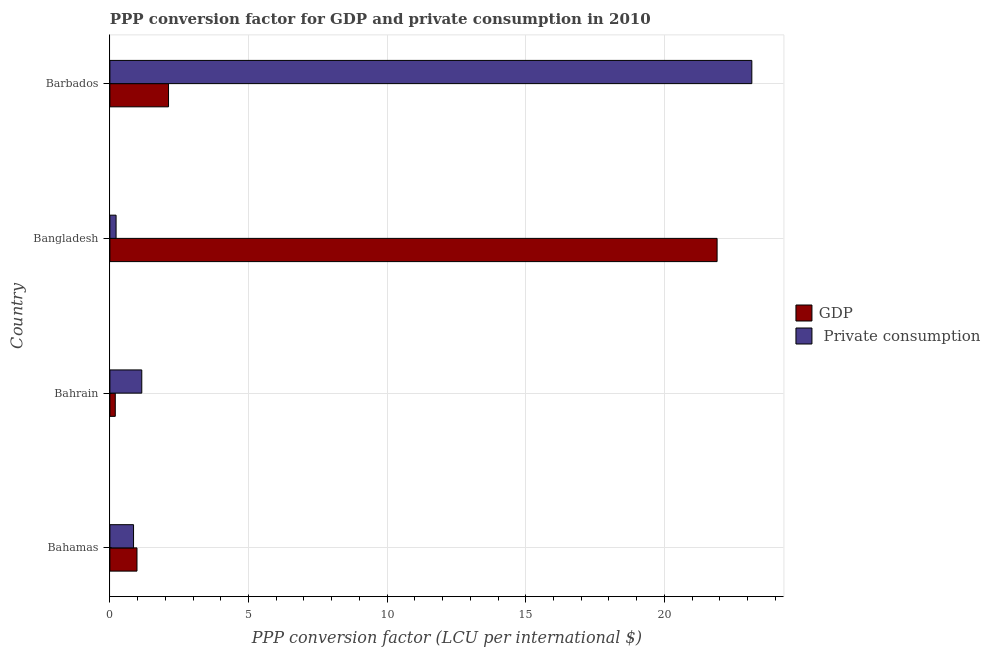Are the number of bars on each tick of the Y-axis equal?
Your answer should be very brief. Yes. How many bars are there on the 3rd tick from the top?
Make the answer very short. 2. How many bars are there on the 2nd tick from the bottom?
Your response must be concise. 2. What is the label of the 4th group of bars from the top?
Keep it short and to the point. Bahamas. In how many cases, is the number of bars for a given country not equal to the number of legend labels?
Your answer should be compact. 0. What is the ppp conversion factor for private consumption in Bahamas?
Your answer should be compact. 0.85. Across all countries, what is the maximum ppp conversion factor for gdp?
Ensure brevity in your answer.  21.9. Across all countries, what is the minimum ppp conversion factor for gdp?
Your answer should be very brief. 0.19. In which country was the ppp conversion factor for private consumption maximum?
Give a very brief answer. Barbados. In which country was the ppp conversion factor for gdp minimum?
Ensure brevity in your answer.  Bahrain. What is the total ppp conversion factor for private consumption in the graph?
Keep it short and to the point. 25.38. What is the difference between the ppp conversion factor for gdp in Bahrain and that in Barbados?
Offer a very short reply. -1.92. What is the difference between the ppp conversion factor for gdp in Bangladesh and the ppp conversion factor for private consumption in Bahamas?
Provide a short and direct response. 21.05. What is the average ppp conversion factor for gdp per country?
Make the answer very short. 6.3. What is the difference between the ppp conversion factor for private consumption and ppp conversion factor for gdp in Bangladesh?
Offer a terse response. -21.68. In how many countries, is the ppp conversion factor for gdp greater than 6 LCU?
Your answer should be compact. 1. What is the ratio of the ppp conversion factor for gdp in Bahamas to that in Bangladesh?
Give a very brief answer. 0.04. Is the ppp conversion factor for private consumption in Bahamas less than that in Barbados?
Ensure brevity in your answer.  Yes. What is the difference between the highest and the second highest ppp conversion factor for private consumption?
Ensure brevity in your answer.  22. What is the difference between the highest and the lowest ppp conversion factor for gdp?
Provide a succinct answer. 21.71. Is the sum of the ppp conversion factor for gdp in Bangladesh and Barbados greater than the maximum ppp conversion factor for private consumption across all countries?
Provide a succinct answer. Yes. What does the 1st bar from the top in Bahrain represents?
Keep it short and to the point.  Private consumption. What does the 1st bar from the bottom in Bahamas represents?
Offer a very short reply. GDP. Are all the bars in the graph horizontal?
Your response must be concise. Yes. How many countries are there in the graph?
Your answer should be very brief. 4. What is the difference between two consecutive major ticks on the X-axis?
Your answer should be very brief. 5. Are the values on the major ticks of X-axis written in scientific E-notation?
Provide a short and direct response. No. Where does the legend appear in the graph?
Keep it short and to the point. Center right. How many legend labels are there?
Give a very brief answer. 2. How are the legend labels stacked?
Give a very brief answer. Vertical. What is the title of the graph?
Keep it short and to the point. PPP conversion factor for GDP and private consumption in 2010. Does "Nitrous oxide emissions" appear as one of the legend labels in the graph?
Offer a very short reply. No. What is the label or title of the X-axis?
Ensure brevity in your answer.  PPP conversion factor (LCU per international $). What is the label or title of the Y-axis?
Provide a short and direct response. Country. What is the PPP conversion factor (LCU per international $) in GDP in Bahamas?
Offer a very short reply. 0.98. What is the PPP conversion factor (LCU per international $) of  Private consumption in Bahamas?
Provide a short and direct response. 0.85. What is the PPP conversion factor (LCU per international $) of GDP in Bahrain?
Provide a succinct answer. 0.19. What is the PPP conversion factor (LCU per international $) of  Private consumption in Bahrain?
Offer a very short reply. 1.15. What is the PPP conversion factor (LCU per international $) of GDP in Bangladesh?
Make the answer very short. 21.9. What is the PPP conversion factor (LCU per international $) of  Private consumption in Bangladesh?
Make the answer very short. 0.22. What is the PPP conversion factor (LCU per international $) in GDP in Barbados?
Your answer should be very brief. 2.12. What is the PPP conversion factor (LCU per international $) in  Private consumption in Barbados?
Give a very brief answer. 23.15. Across all countries, what is the maximum PPP conversion factor (LCU per international $) in GDP?
Give a very brief answer. 21.9. Across all countries, what is the maximum PPP conversion factor (LCU per international $) of  Private consumption?
Your answer should be very brief. 23.15. Across all countries, what is the minimum PPP conversion factor (LCU per international $) of GDP?
Give a very brief answer. 0.19. Across all countries, what is the minimum PPP conversion factor (LCU per international $) in  Private consumption?
Your response must be concise. 0.22. What is the total PPP conversion factor (LCU per international $) of GDP in the graph?
Your response must be concise. 25.19. What is the total PPP conversion factor (LCU per international $) of  Private consumption in the graph?
Offer a terse response. 25.38. What is the difference between the PPP conversion factor (LCU per international $) in GDP in Bahamas and that in Bahrain?
Make the answer very short. 0.78. What is the difference between the PPP conversion factor (LCU per international $) of  Private consumption in Bahamas and that in Bahrain?
Offer a very short reply. -0.3. What is the difference between the PPP conversion factor (LCU per international $) of GDP in Bahamas and that in Bangladesh?
Make the answer very short. -20.92. What is the difference between the PPP conversion factor (LCU per international $) of  Private consumption in Bahamas and that in Bangladesh?
Keep it short and to the point. 0.63. What is the difference between the PPP conversion factor (LCU per international $) in GDP in Bahamas and that in Barbados?
Keep it short and to the point. -1.14. What is the difference between the PPP conversion factor (LCU per international $) of  Private consumption in Bahamas and that in Barbados?
Offer a very short reply. -22.3. What is the difference between the PPP conversion factor (LCU per international $) in GDP in Bahrain and that in Bangladesh?
Provide a short and direct response. -21.71. What is the difference between the PPP conversion factor (LCU per international $) of  Private consumption in Bahrain and that in Bangladesh?
Give a very brief answer. 0.93. What is the difference between the PPP conversion factor (LCU per international $) in GDP in Bahrain and that in Barbados?
Offer a terse response. -1.92. What is the difference between the PPP conversion factor (LCU per international $) of  Private consumption in Bahrain and that in Barbados?
Provide a short and direct response. -22. What is the difference between the PPP conversion factor (LCU per international $) of GDP in Bangladesh and that in Barbados?
Your answer should be compact. 19.79. What is the difference between the PPP conversion factor (LCU per international $) in  Private consumption in Bangladesh and that in Barbados?
Provide a short and direct response. -22.93. What is the difference between the PPP conversion factor (LCU per international $) in GDP in Bahamas and the PPP conversion factor (LCU per international $) in  Private consumption in Bahrain?
Ensure brevity in your answer.  -0.17. What is the difference between the PPP conversion factor (LCU per international $) of GDP in Bahamas and the PPP conversion factor (LCU per international $) of  Private consumption in Bangladesh?
Provide a short and direct response. 0.75. What is the difference between the PPP conversion factor (LCU per international $) of GDP in Bahamas and the PPP conversion factor (LCU per international $) of  Private consumption in Barbados?
Your answer should be compact. -22.18. What is the difference between the PPP conversion factor (LCU per international $) of GDP in Bahrain and the PPP conversion factor (LCU per international $) of  Private consumption in Bangladesh?
Provide a succinct answer. -0.03. What is the difference between the PPP conversion factor (LCU per international $) of GDP in Bahrain and the PPP conversion factor (LCU per international $) of  Private consumption in Barbados?
Provide a succinct answer. -22.96. What is the difference between the PPP conversion factor (LCU per international $) in GDP in Bangladesh and the PPP conversion factor (LCU per international $) in  Private consumption in Barbados?
Your response must be concise. -1.25. What is the average PPP conversion factor (LCU per international $) in GDP per country?
Ensure brevity in your answer.  6.3. What is the average PPP conversion factor (LCU per international $) of  Private consumption per country?
Make the answer very short. 6.35. What is the difference between the PPP conversion factor (LCU per international $) in GDP and PPP conversion factor (LCU per international $) in  Private consumption in Bahamas?
Keep it short and to the point. 0.12. What is the difference between the PPP conversion factor (LCU per international $) in GDP and PPP conversion factor (LCU per international $) in  Private consumption in Bahrain?
Offer a terse response. -0.96. What is the difference between the PPP conversion factor (LCU per international $) in GDP and PPP conversion factor (LCU per international $) in  Private consumption in Bangladesh?
Your answer should be very brief. 21.68. What is the difference between the PPP conversion factor (LCU per international $) of GDP and PPP conversion factor (LCU per international $) of  Private consumption in Barbados?
Provide a short and direct response. -21.04. What is the ratio of the PPP conversion factor (LCU per international $) of GDP in Bahamas to that in Bahrain?
Provide a succinct answer. 5.03. What is the ratio of the PPP conversion factor (LCU per international $) in  Private consumption in Bahamas to that in Bahrain?
Offer a terse response. 0.74. What is the ratio of the PPP conversion factor (LCU per international $) in GDP in Bahamas to that in Bangladesh?
Provide a succinct answer. 0.04. What is the ratio of the PPP conversion factor (LCU per international $) of  Private consumption in Bahamas to that in Bangladesh?
Your response must be concise. 3.83. What is the ratio of the PPP conversion factor (LCU per international $) in GDP in Bahamas to that in Barbados?
Offer a terse response. 0.46. What is the ratio of the PPP conversion factor (LCU per international $) in  Private consumption in Bahamas to that in Barbados?
Your answer should be very brief. 0.04. What is the ratio of the PPP conversion factor (LCU per international $) of GDP in Bahrain to that in Bangladesh?
Provide a succinct answer. 0.01. What is the ratio of the PPP conversion factor (LCU per international $) of  Private consumption in Bahrain to that in Bangladesh?
Provide a short and direct response. 5.16. What is the ratio of the PPP conversion factor (LCU per international $) of GDP in Bahrain to that in Barbados?
Your response must be concise. 0.09. What is the ratio of the PPP conversion factor (LCU per international $) of  Private consumption in Bahrain to that in Barbados?
Give a very brief answer. 0.05. What is the ratio of the PPP conversion factor (LCU per international $) in GDP in Bangladesh to that in Barbados?
Your response must be concise. 10.36. What is the ratio of the PPP conversion factor (LCU per international $) of  Private consumption in Bangladesh to that in Barbados?
Provide a short and direct response. 0.01. What is the difference between the highest and the second highest PPP conversion factor (LCU per international $) of GDP?
Offer a terse response. 19.79. What is the difference between the highest and the second highest PPP conversion factor (LCU per international $) of  Private consumption?
Offer a terse response. 22. What is the difference between the highest and the lowest PPP conversion factor (LCU per international $) in GDP?
Offer a terse response. 21.71. What is the difference between the highest and the lowest PPP conversion factor (LCU per international $) in  Private consumption?
Make the answer very short. 22.93. 